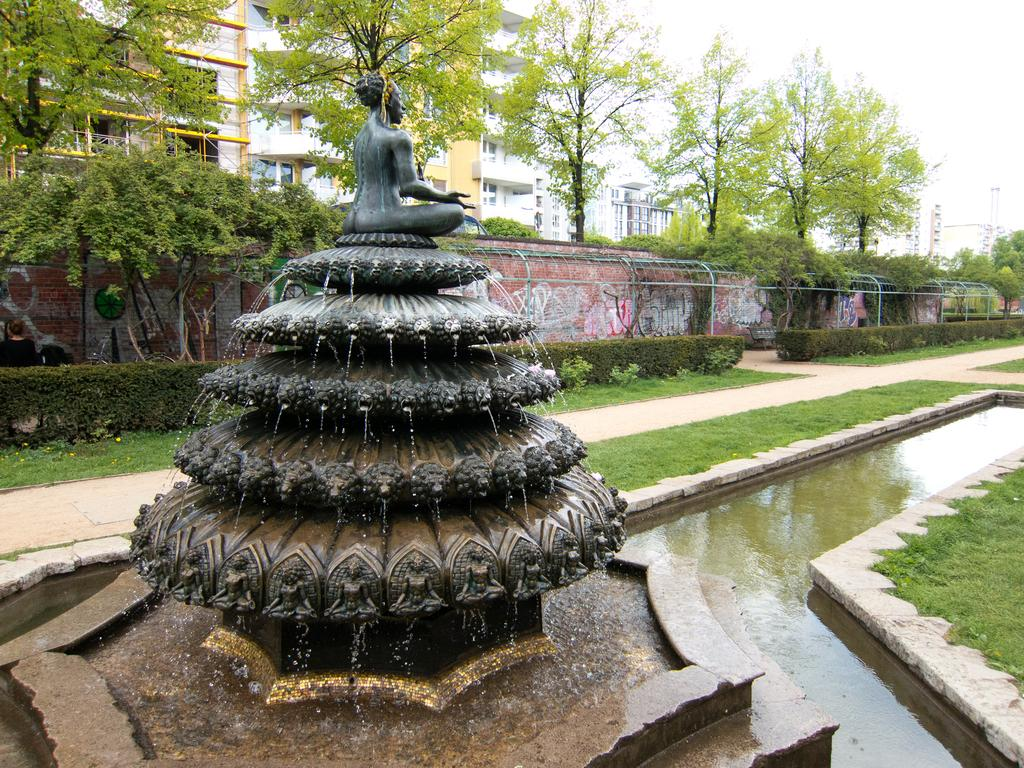What is the main subject of the image? There is a sculpture in the image. What else can be seen in the image besides the sculpture? There is a fountain, water, grass, plants, a wall, trees, buildings, and the sky visible in the image. Can you describe the fountain in the image? The fountain is a water feature that can be seen in the image. What type of vegetation is present in the image? There are plants and trees in the image. What is visible in the background of the image? Buildings and the sky are visible in the background of the image. How many jellyfish are swimming in the water in the image? There are no jellyfish present in the image; it features a sculpture, fountain, and other elements. What finger is pointing at the sculpture in the image? There are no fingers or people visible in the image, so it is not possible to determine if any fingers are pointing at the sculpture. 